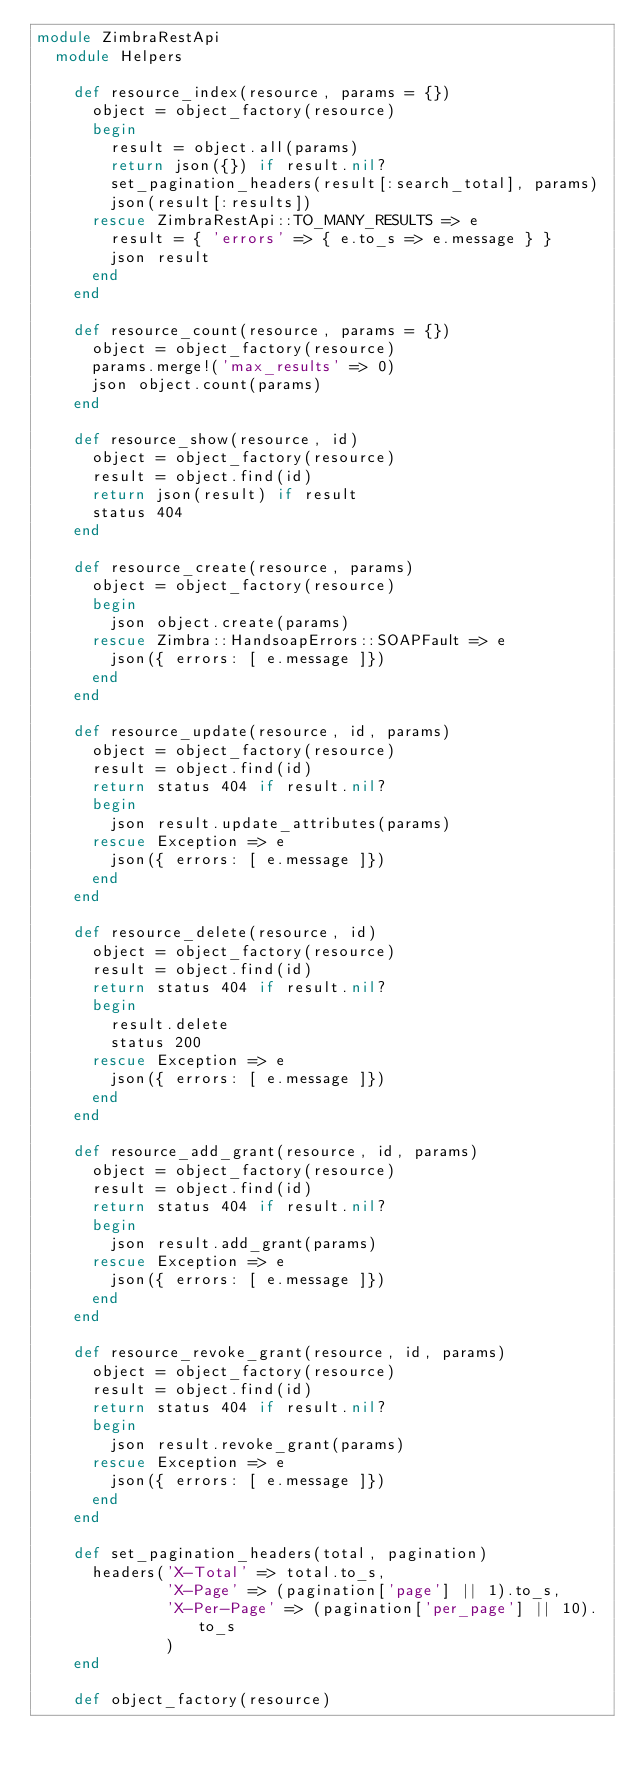Convert code to text. <code><loc_0><loc_0><loc_500><loc_500><_Ruby_>module ZimbraRestApi
  module Helpers

    def resource_index(resource, params = {})
      object = object_factory(resource)
      begin
        result = object.all(params)
        return json({}) if result.nil?
        set_pagination_headers(result[:search_total], params)
        json(result[:results])
      rescue ZimbraRestApi::TO_MANY_RESULTS => e
        result = { 'errors' => { e.to_s => e.message } }
        json result
      end
    end

    def resource_count(resource, params = {})
      object = object_factory(resource)
      params.merge!('max_results' => 0)
      json object.count(params)
    end

    def resource_show(resource, id)
      object = object_factory(resource)
      result = object.find(id)
      return json(result) if result
      status 404
    end

    def resource_create(resource, params)
      object = object_factory(resource)
      begin
        json object.create(params)
      rescue Zimbra::HandsoapErrors::SOAPFault => e
        json({ errors: [ e.message ]})
      end
    end

    def resource_update(resource, id, params)
      object = object_factory(resource)
      result = object.find(id)
      return status 404 if result.nil?
      begin
        json result.update_attributes(params)
      rescue Exception => e
        json({ errors: [ e.message ]})
      end
    end

    def resource_delete(resource, id)
      object = object_factory(resource)
      result = object.find(id)
      return status 404 if result.nil?
      begin
        result.delete
        status 200
      rescue Exception => e
        json({ errors: [ e.message ]})
      end
    end

    def resource_add_grant(resource, id, params)
      object = object_factory(resource)
      result = object.find(id)
      return status 404 if result.nil?
      begin
        json result.add_grant(params)
      rescue Exception => e
        json({ errors: [ e.message ]})
      end
    end

    def resource_revoke_grant(resource, id, params)
      object = object_factory(resource)
      result = object.find(id)
      return status 404 if result.nil?
      begin
        json result.revoke_grant(params)
      rescue Exception => e
        json({ errors: [ e.message ]})
      end
    end

    def set_pagination_headers(total, pagination)
      headers('X-Total' => total.to_s,
              'X-Page' => (pagination['page'] || 1).to_s,
              'X-Per-Page' => (pagination['per_page'] || 10).to_s
              )
    end

    def object_factory(resource)</code> 